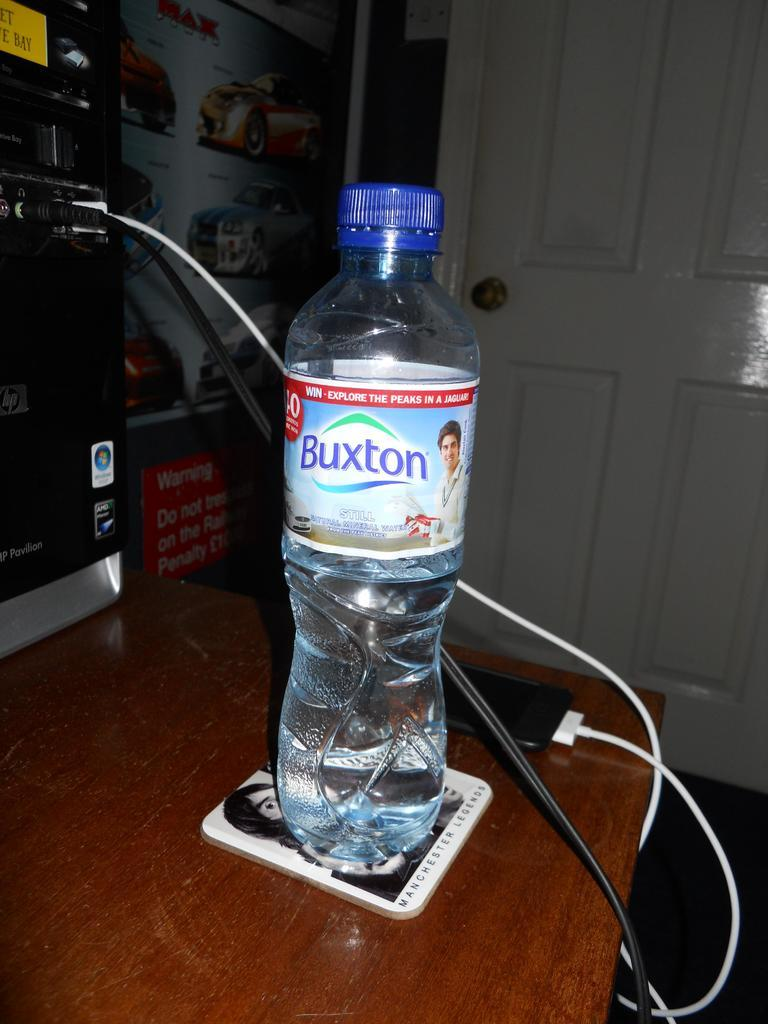Provide a one-sentence caption for the provided image. A Buxton brand water bottle sits on a coaster. 